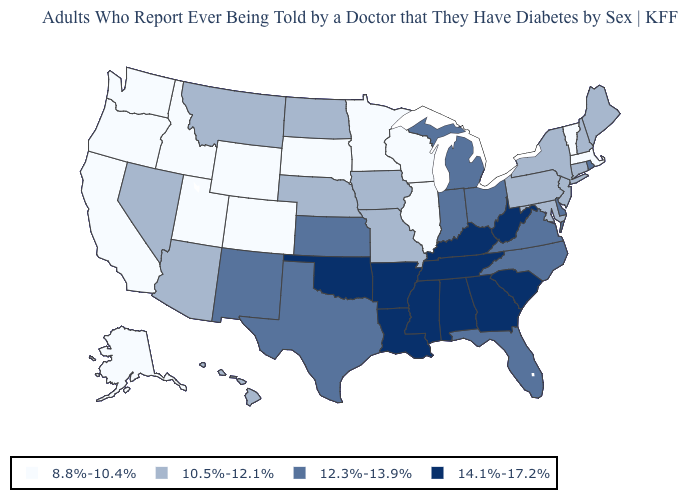Name the states that have a value in the range 14.1%-17.2%?
Be succinct. Alabama, Arkansas, Georgia, Kentucky, Louisiana, Mississippi, Oklahoma, South Carolina, Tennessee, West Virginia. How many symbols are there in the legend?
Short answer required. 4. Name the states that have a value in the range 8.8%-10.4%?
Be succinct. Alaska, California, Colorado, Idaho, Illinois, Massachusetts, Minnesota, Oregon, South Dakota, Utah, Vermont, Washington, Wisconsin, Wyoming. What is the value of Oregon?
Quick response, please. 8.8%-10.4%. Name the states that have a value in the range 14.1%-17.2%?
Keep it brief. Alabama, Arkansas, Georgia, Kentucky, Louisiana, Mississippi, Oklahoma, South Carolina, Tennessee, West Virginia. What is the lowest value in the USA?
Write a very short answer. 8.8%-10.4%. Among the states that border Virginia , which have the lowest value?
Be succinct. Maryland. Name the states that have a value in the range 12.3%-13.9%?
Short answer required. Delaware, Florida, Indiana, Kansas, Michigan, New Mexico, North Carolina, Ohio, Rhode Island, Texas, Virginia. Name the states that have a value in the range 12.3%-13.9%?
Write a very short answer. Delaware, Florida, Indiana, Kansas, Michigan, New Mexico, North Carolina, Ohio, Rhode Island, Texas, Virginia. Which states have the lowest value in the MidWest?
Quick response, please. Illinois, Minnesota, South Dakota, Wisconsin. What is the highest value in the USA?
Quick response, please. 14.1%-17.2%. What is the value of Connecticut?
Be succinct. 10.5%-12.1%. What is the value of North Dakota?
Answer briefly. 10.5%-12.1%. Does Nebraska have a lower value than South Carolina?
Answer briefly. Yes. Name the states that have a value in the range 14.1%-17.2%?
Concise answer only. Alabama, Arkansas, Georgia, Kentucky, Louisiana, Mississippi, Oklahoma, South Carolina, Tennessee, West Virginia. 